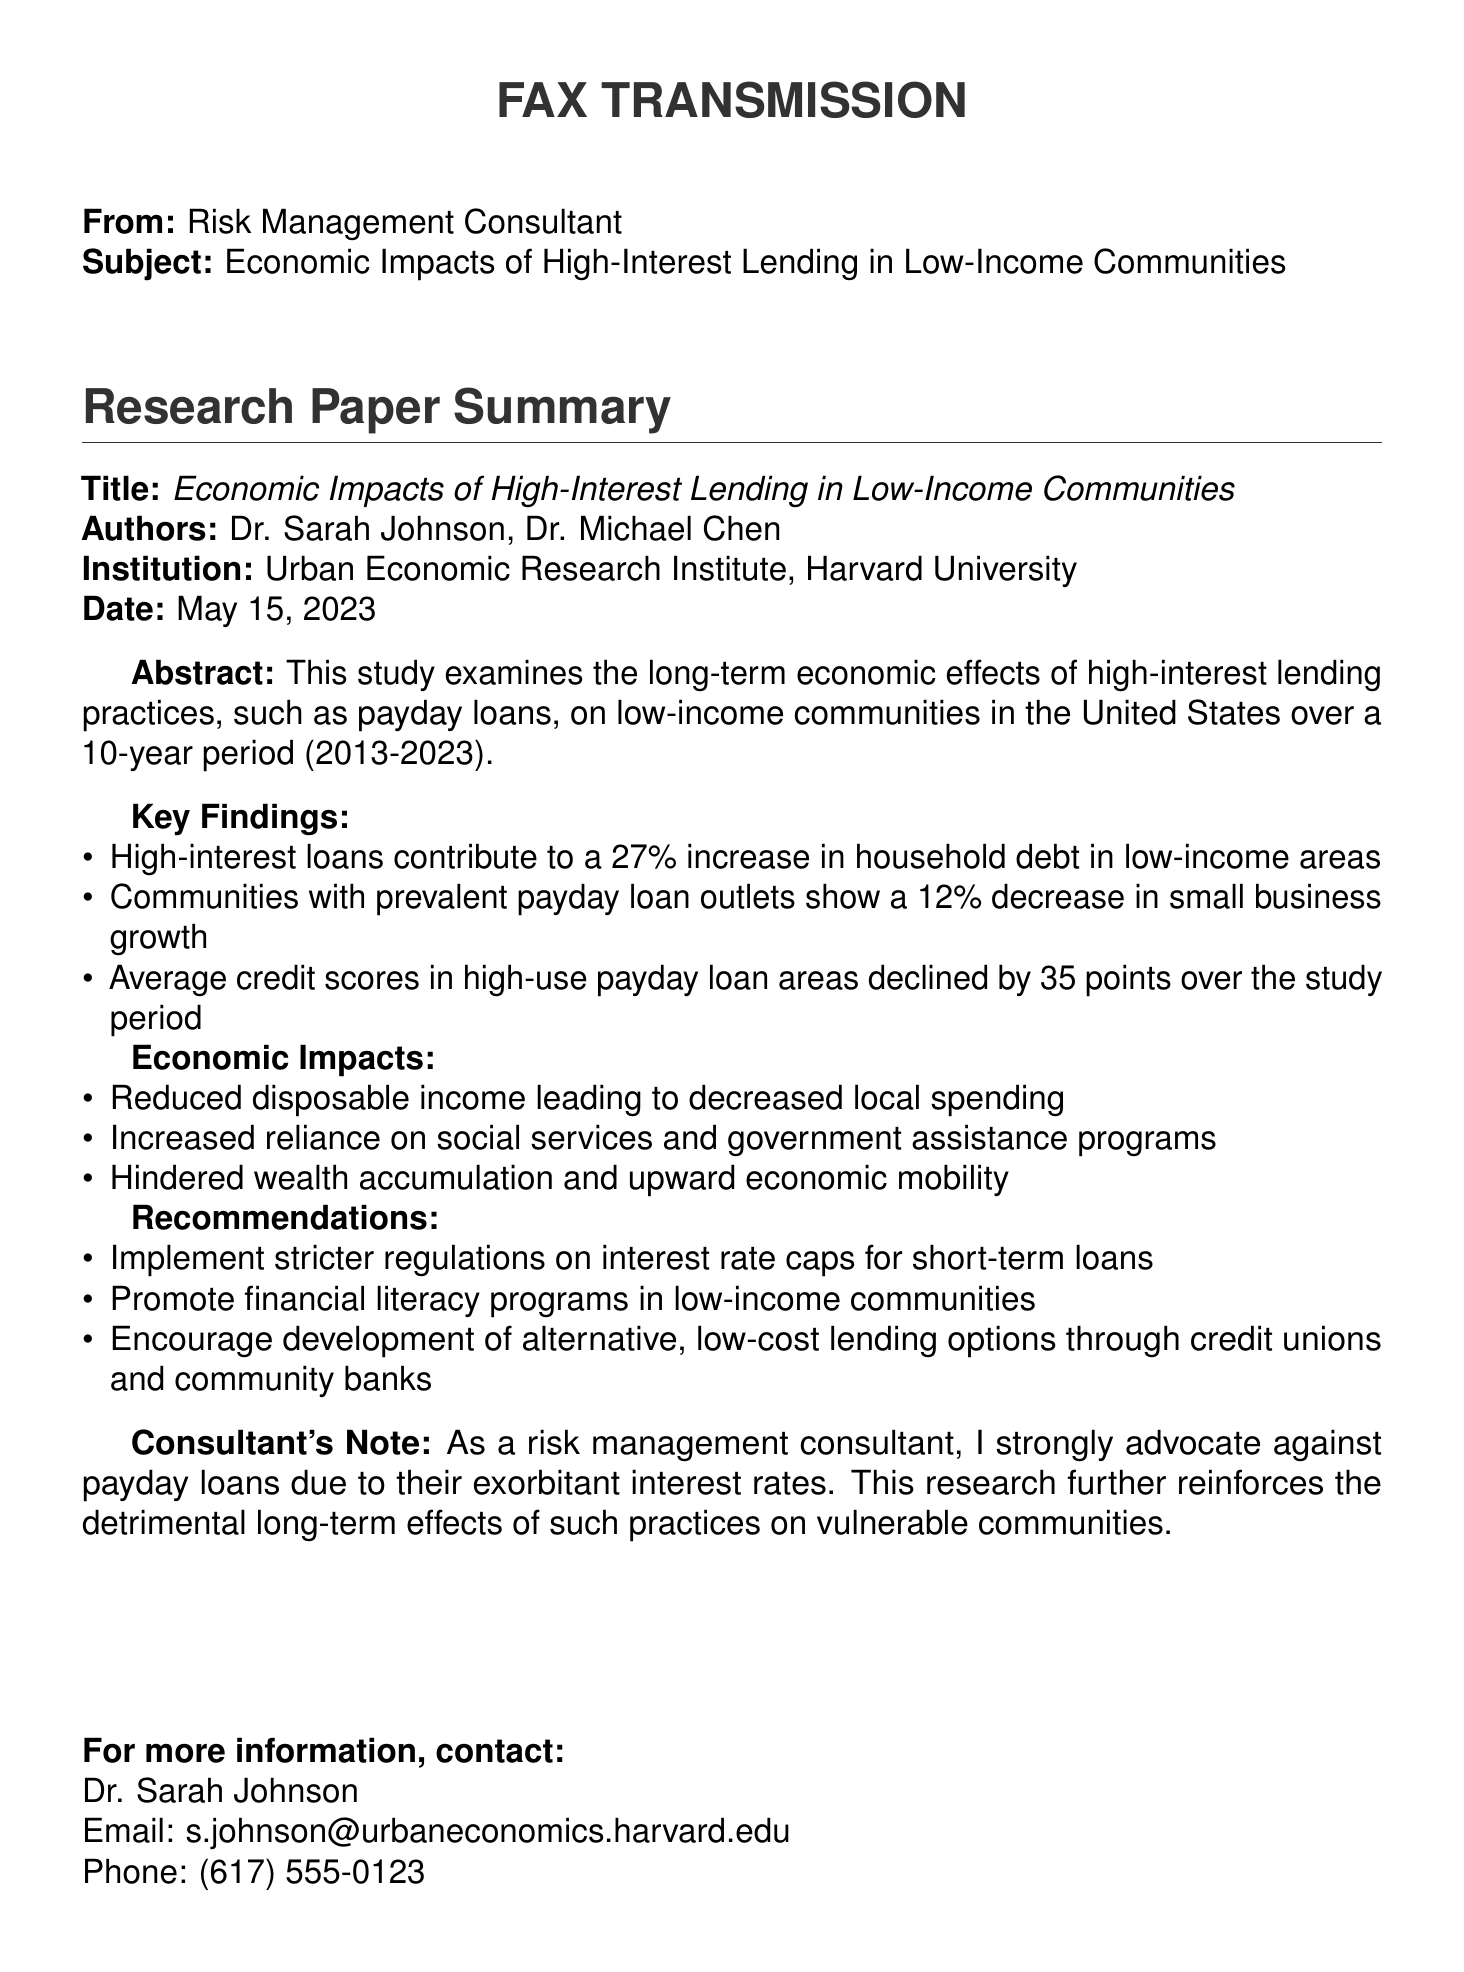what is the title of the research paper? The title is provided in the document under "Title," highlighting the focus on economic impacts.
Answer: Economic Impacts of High-Interest Lending in Low-Income Communities who are the authors of the research paper? The authors are listed at the beginning of the summary section under "Authors."
Answer: Dr. Sarah Johnson, Dr. Michael Chen what institution conducted the research? The institution is mentioned right after the authors, indicating where the research was conducted.
Answer: Urban Economic Research Institute, Harvard University what is the percentage increase in household debt in low-income areas due to high-interest loans? This percentage is noted under the "Key Findings" section, reflecting the study's results on household debt.
Answer: 27% what impact does the prevalence of payday loan outlets have on small business growth? The effect on small business growth is detailed in the "Key Findings," indicating a negative trend.
Answer: 12% decrease how many points did average credit scores decline in high-use payday loan areas over the study period? The decline in credit scores is listed under "Key Findings," providing a specific number.
Answer: 35 points what is one recommendation made in the document? Recommendations are provided at the end of the summary, focusing on improving lending practices.
Answer: Implement stricter regulations on interest rate caps for short-term loans what date was the research paper published? The publication date is included at the beginning of the document under "Date."
Answer: May 15, 2023 what type of document is this? The document is classified under the title presented at the top, indicating its purpose.
Answer: Fax Transmission 